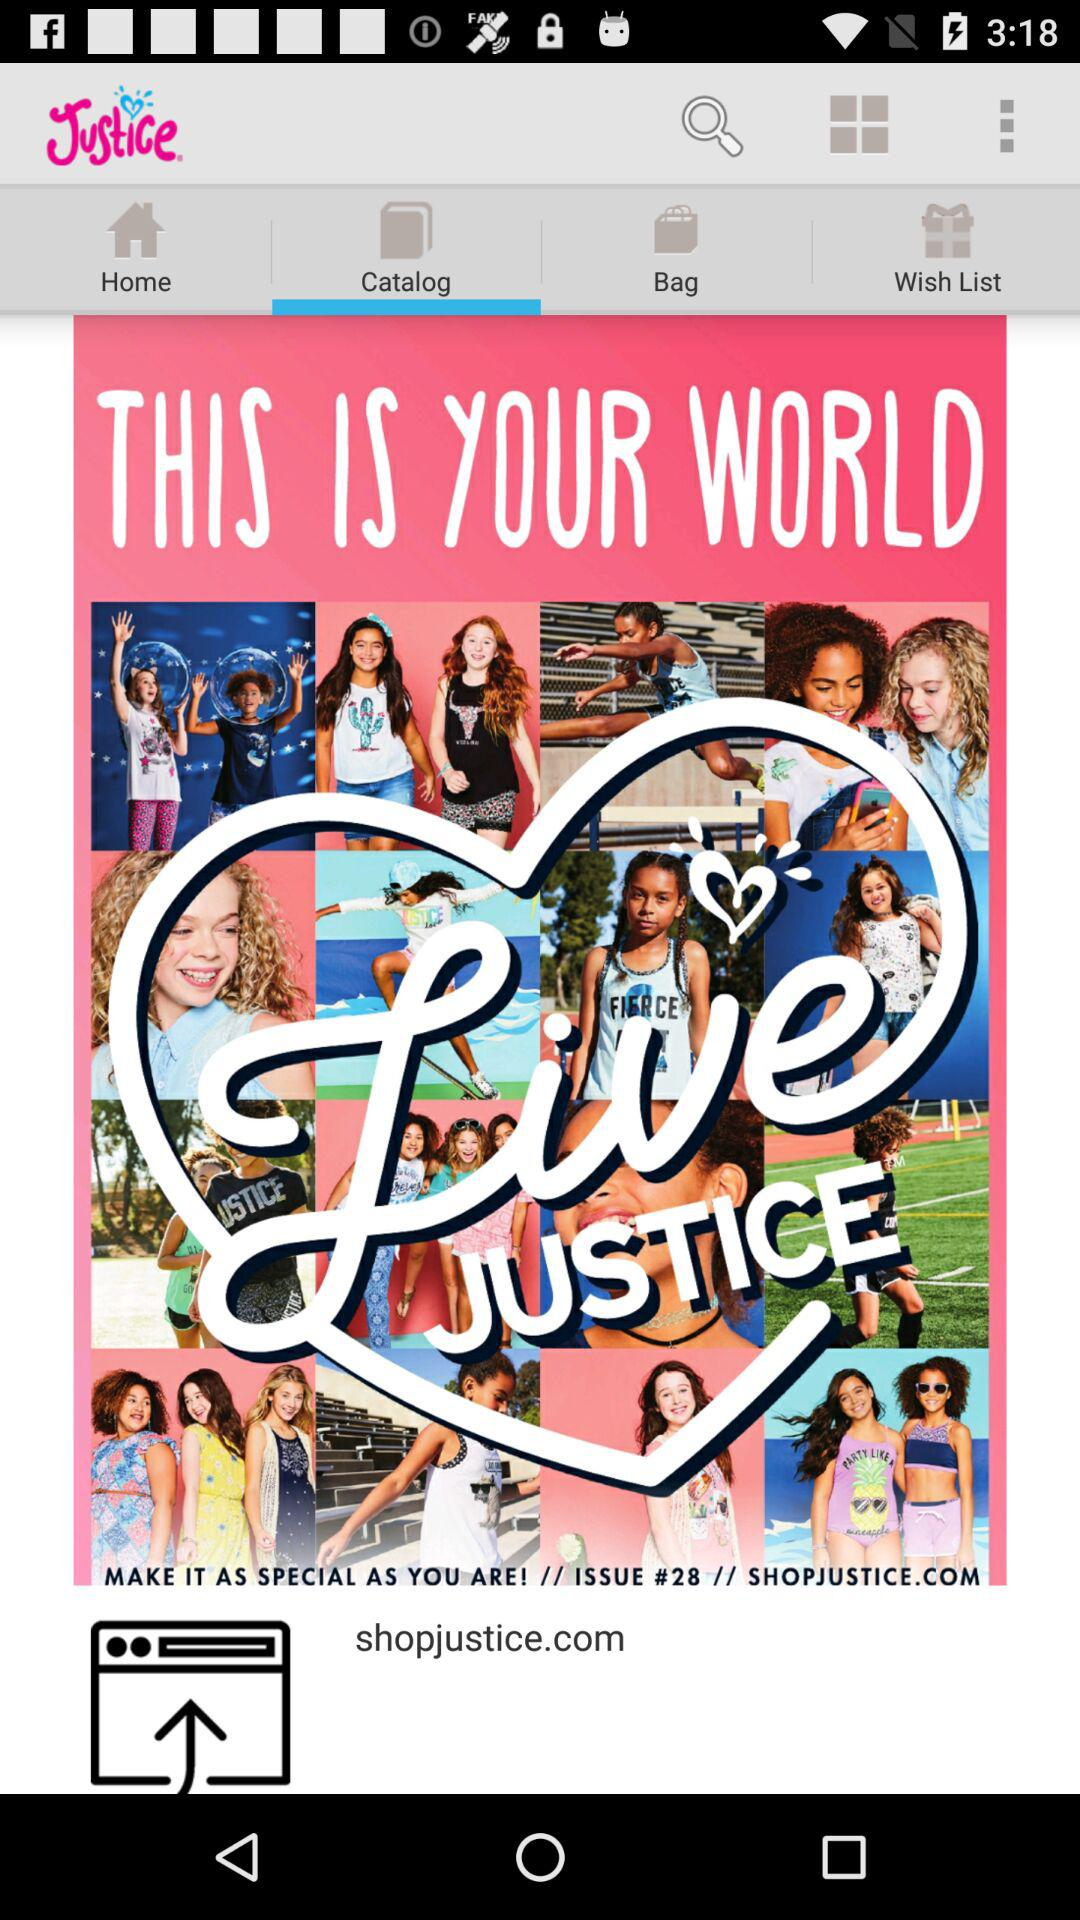Which tab is selected? The selected tab is "Catalog". 